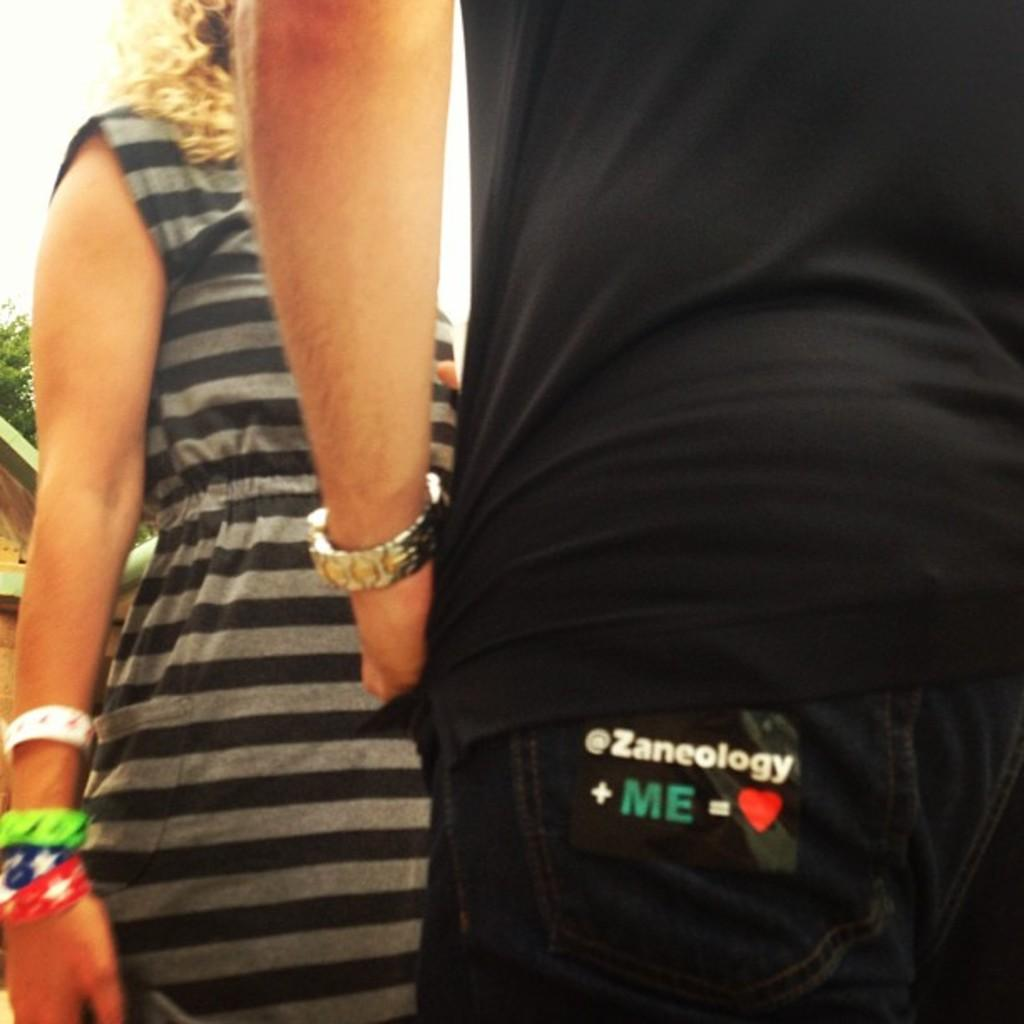How many people are in the image? There are two people in the image. What else can be seen in the image besides the people? There is text and symbols, a house, a tree, and the sky visible on the left side of the image. What type of crown is the writer wearing in the image? There is no writer or crown present in the image. 